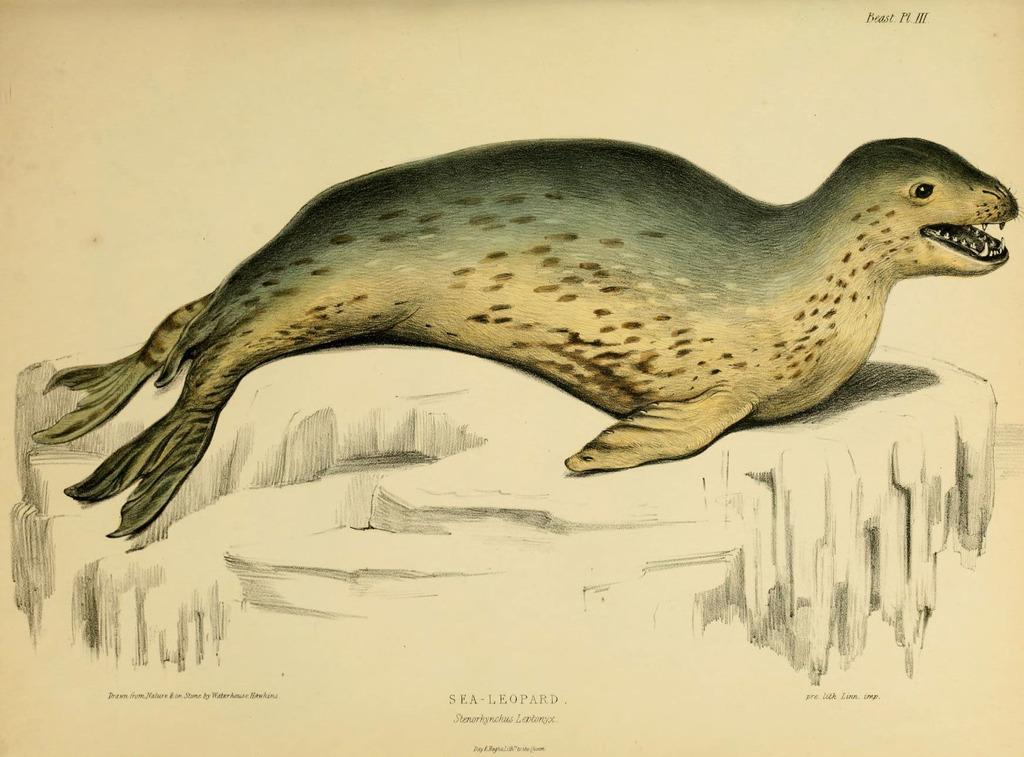What type of artwork is depicted in the image? The image appears to be a painting. What animal can be seen in the painting? There is a seal in the painting. Where is the seal located in the painting? The seal is on a rock. Are there any words or letters in the painting? Yes, there is text present in the painting. What type of playground equipment can be seen in the painting? There is no playground equipment present in the painting; it features a seal on a rock and text. What territory does the seal claim as its own in the painting? The painting does not depict the seal claiming any territory; it simply shows the seal on a rock. 